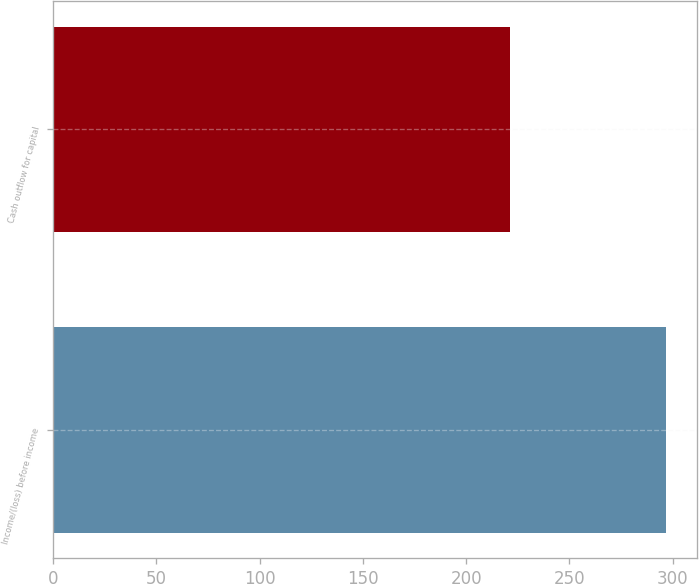Convert chart. <chart><loc_0><loc_0><loc_500><loc_500><bar_chart><fcel>Income/(loss) before income<fcel>Cash outflow for capital<nl><fcel>297<fcel>221<nl></chart> 